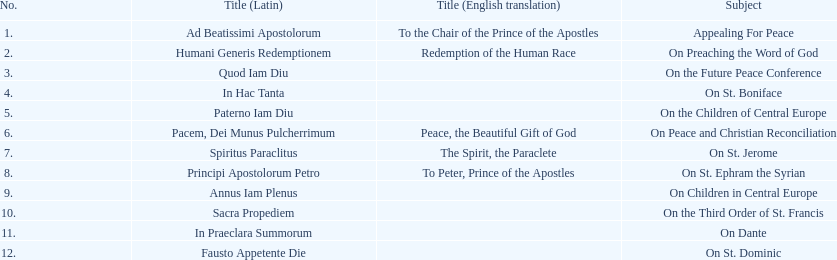How many titles are listed in the table? 12. 